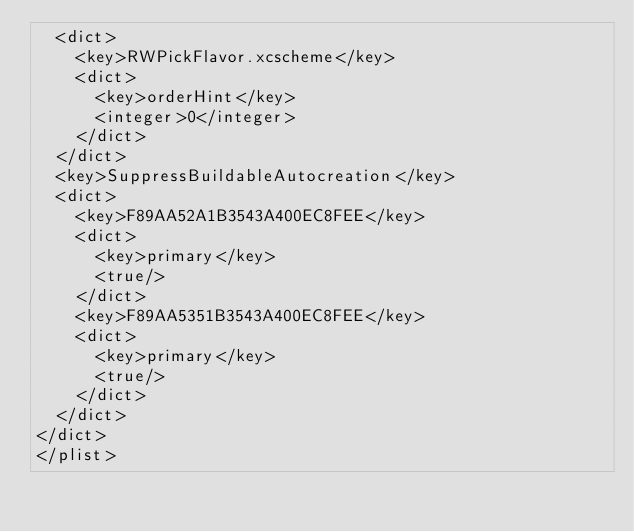<code> <loc_0><loc_0><loc_500><loc_500><_XML_>	<dict>
		<key>RWPickFlavor.xcscheme</key>
		<dict>
			<key>orderHint</key>
			<integer>0</integer>
		</dict>
	</dict>
	<key>SuppressBuildableAutocreation</key>
	<dict>
		<key>F89AA52A1B3543A400EC8FEE</key>
		<dict>
			<key>primary</key>
			<true/>
		</dict>
		<key>F89AA5351B3543A400EC8FEE</key>
		<dict>
			<key>primary</key>
			<true/>
		</dict>
	</dict>
</dict>
</plist>
</code> 